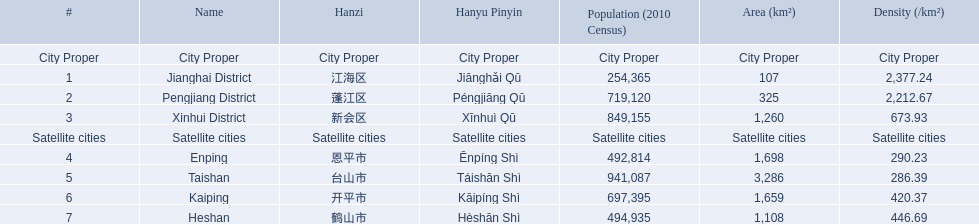What are the satellite cities of jiangmen? Enping, Taishan, Kaiping, Heshan. Of these cities, which has the highest density? Taishan. 